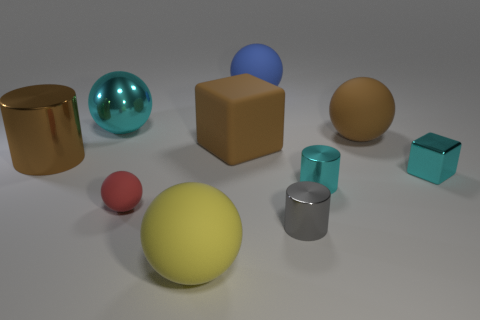Subtract all brown spheres. How many spheres are left? 4 Subtract all large yellow rubber spheres. How many spheres are left? 4 Subtract all brown spheres. Subtract all red cylinders. How many spheres are left? 4 Subtract all cubes. How many objects are left? 8 Subtract 0 gray spheres. How many objects are left? 10 Subtract all big green metal cylinders. Subtract all matte blocks. How many objects are left? 9 Add 1 big brown things. How many big brown things are left? 4 Add 5 small cyan cylinders. How many small cyan cylinders exist? 6 